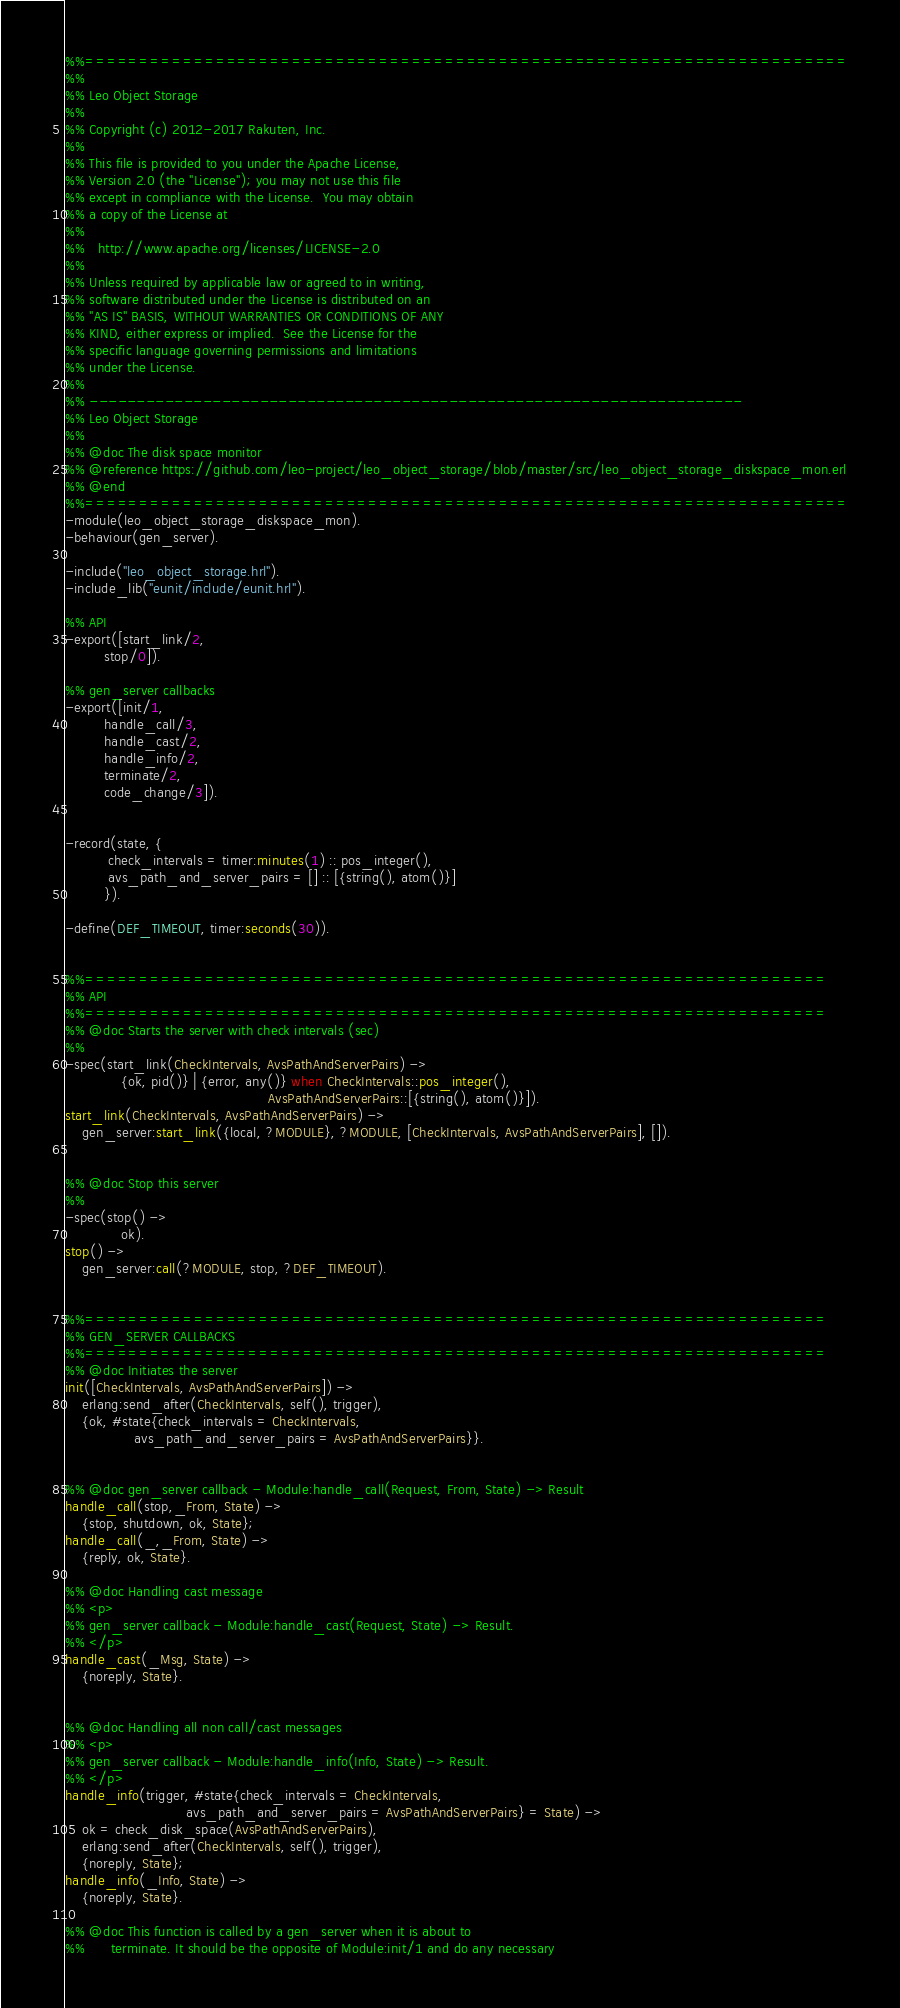Convert code to text. <code><loc_0><loc_0><loc_500><loc_500><_Erlang_>%%======================================================================
%%
%% Leo Object Storage
%%
%% Copyright (c) 2012-2017 Rakuten, Inc.
%%
%% This file is provided to you under the Apache License,
%% Version 2.0 (the "License"); you may not use this file
%% except in compliance with the License.  You may obtain
%% a copy of the License at
%%
%%   http://www.apache.org/licenses/LICENSE-2.0
%%
%% Unless required by applicable law or agreed to in writing,
%% software distributed under the License is distributed on an
%% "AS IS" BASIS, WITHOUT WARRANTIES OR CONDITIONS OF ANY
%% KIND, either express or implied.  See the License for the
%% specific language governing permissions and limitations
%% under the License.
%%
%% ---------------------------------------------------------------------
%% Leo Object Storage
%%
%% @doc The disk space monitor
%% @reference https://github.com/leo-project/leo_object_storage/blob/master/src/leo_object_storage_diskspace_mon.erl
%% @end
%%======================================================================
-module(leo_object_storage_diskspace_mon).
-behaviour(gen_server).

-include("leo_object_storage.hrl").
-include_lib("eunit/include/eunit.hrl").

%% API
-export([start_link/2,
         stop/0]).

%% gen_server callbacks
-export([init/1,
         handle_call/3,
         handle_cast/2,
         handle_info/2,
         terminate/2,
         code_change/3]).


-record(state, {
          check_intervals = timer:minutes(1) :: pos_integer(),
          avs_path_and_server_pairs = [] :: [{string(), atom()}]
         }).

-define(DEF_TIMEOUT, timer:seconds(30)).


%%====================================================================
%% API
%%====================================================================
%% @doc Starts the server with check intervals (sec)
%%
-spec(start_link(CheckIntervals, AvsPathAndServerPairs) ->
             {ok, pid()} | {error, any()} when CheckIntervals::pos_integer(),
                                               AvsPathAndServerPairs::[{string(), atom()}]).
start_link(CheckIntervals, AvsPathAndServerPairs) ->
    gen_server:start_link({local, ?MODULE}, ?MODULE, [CheckIntervals, AvsPathAndServerPairs], []).


%% @doc Stop this server
%%
-spec(stop() ->
             ok).
stop() ->
    gen_server:call(?MODULE, stop, ?DEF_TIMEOUT).


%%====================================================================
%% GEN_SERVER CALLBACKS
%%====================================================================
%% @doc Initiates the server
init([CheckIntervals, AvsPathAndServerPairs]) ->
    erlang:send_after(CheckIntervals, self(), trigger),
    {ok, #state{check_intervals = CheckIntervals,
                avs_path_and_server_pairs = AvsPathAndServerPairs}}.


%% @doc gen_server callback - Module:handle_call(Request, From, State) -> Result
handle_call(stop,_From, State) ->
    {stop, shutdown, ok, State};
handle_call(_,_From, State) ->
    {reply, ok, State}.

%% @doc Handling cast message
%% <p>
%% gen_server callback - Module:handle_cast(Request, State) -> Result.
%% </p>
handle_cast(_Msg, State) ->
    {noreply, State}.


%% @doc Handling all non call/cast messages
%% <p>
%% gen_server callback - Module:handle_info(Info, State) -> Result.
%% </p>
handle_info(trigger, #state{check_intervals = CheckIntervals,
                            avs_path_and_server_pairs = AvsPathAndServerPairs} = State) ->
    ok = check_disk_space(AvsPathAndServerPairs),
    erlang:send_after(CheckIntervals, self(), trigger),
    {noreply, State};
handle_info(_Info, State) ->
    {noreply, State}.

%% @doc This function is called by a gen_server when it is about to
%%      terminate. It should be the opposite of Module:init/1 and do any necessary</code> 